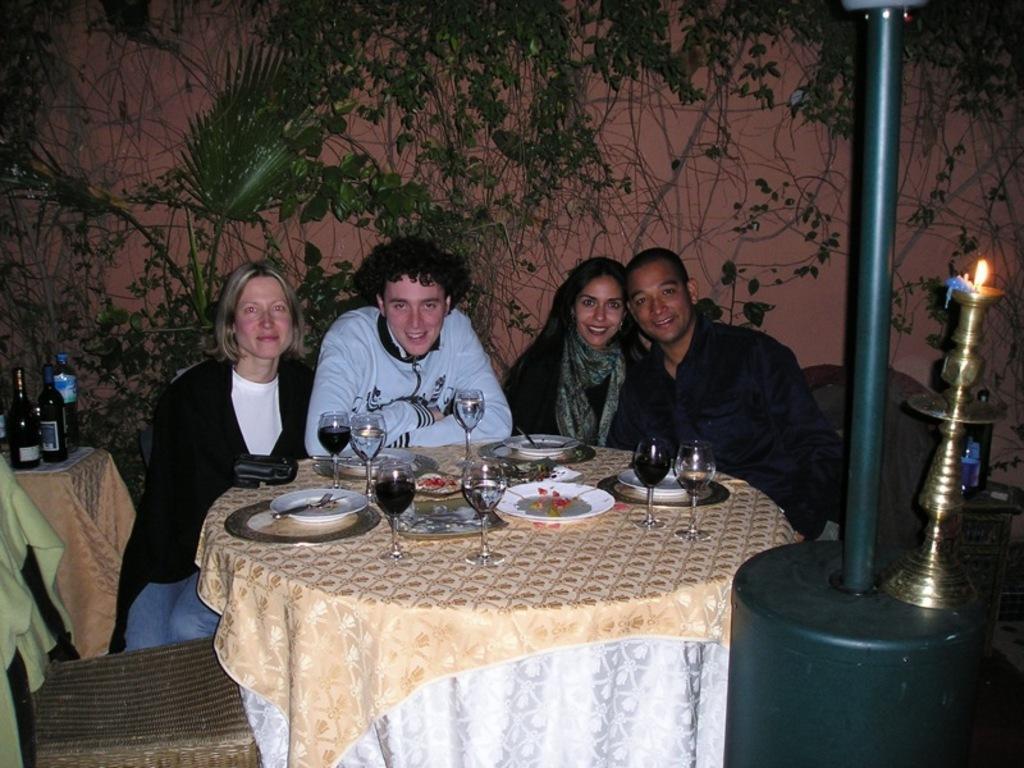Please provide a concise description of this image. There are four members sitting in front of a table in their chairs. On the table there are some plates, glasses and a cloth placed here. There are men and women here. In the background there are some plants and walls here. 